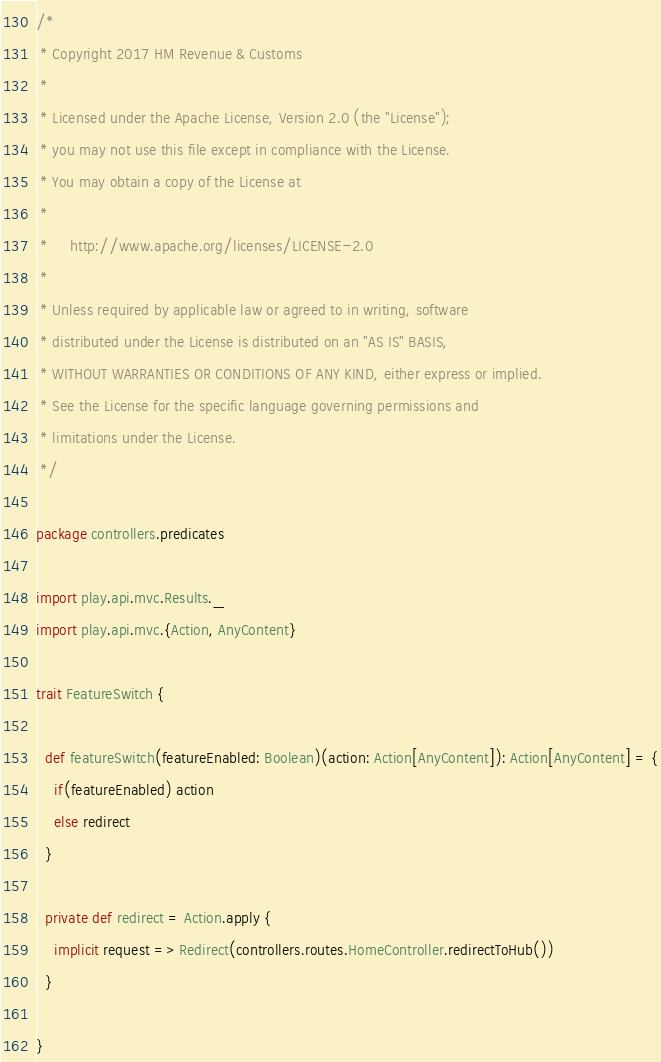<code> <loc_0><loc_0><loc_500><loc_500><_Scala_>/*
 * Copyright 2017 HM Revenue & Customs
 *
 * Licensed under the Apache License, Version 2.0 (the "License");
 * you may not use this file except in compliance with the License.
 * You may obtain a copy of the License at
 *
 *     http://www.apache.org/licenses/LICENSE-2.0
 *
 * Unless required by applicable law or agreed to in writing, software
 * distributed under the License is distributed on an "AS IS" BASIS,
 * WITHOUT WARRANTIES OR CONDITIONS OF ANY KIND, either express or implied.
 * See the License for the specific language governing permissions and
 * limitations under the License.
 */

package controllers.predicates

import play.api.mvc.Results._
import play.api.mvc.{Action, AnyContent}

trait FeatureSwitch {

  def featureSwitch(featureEnabled: Boolean)(action: Action[AnyContent]): Action[AnyContent] = {
    if(featureEnabled) action
    else redirect
  }

  private def redirect = Action.apply {
    implicit request => Redirect(controllers.routes.HomeController.redirectToHub())
  }

}
</code> 